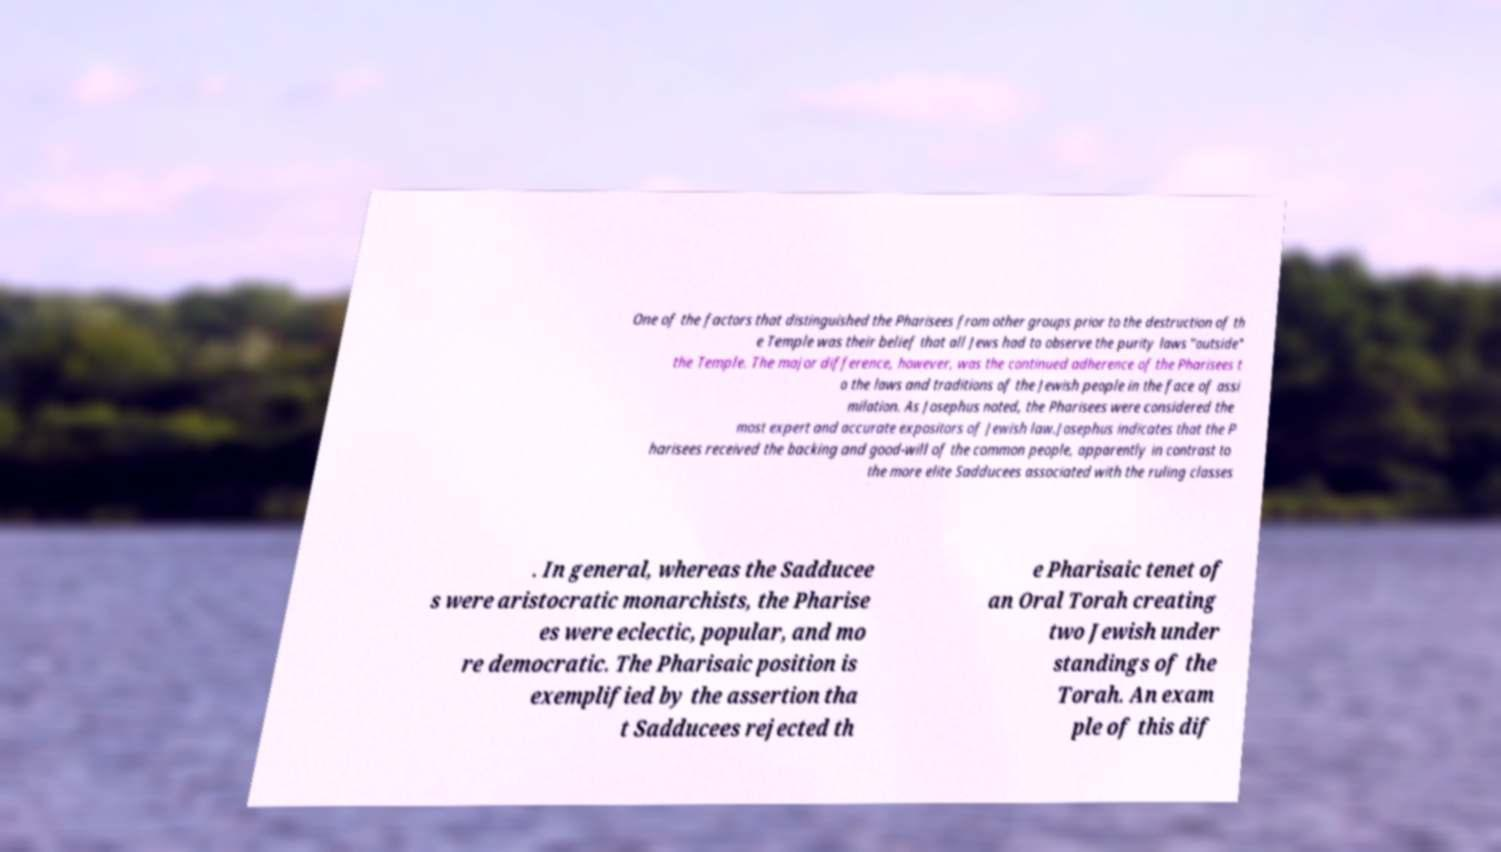I need the written content from this picture converted into text. Can you do that? One of the factors that distinguished the Pharisees from other groups prior to the destruction of th e Temple was their belief that all Jews had to observe the purity laws "outside" the Temple. The major difference, however, was the continued adherence of the Pharisees t o the laws and traditions of the Jewish people in the face of assi milation. As Josephus noted, the Pharisees were considered the most expert and accurate expositors of Jewish law.Josephus indicates that the P harisees received the backing and good-will of the common people, apparently in contrast to the more elite Sadducees associated with the ruling classes . In general, whereas the Sadducee s were aristocratic monarchists, the Pharise es were eclectic, popular, and mo re democratic. The Pharisaic position is exemplified by the assertion tha t Sadducees rejected th e Pharisaic tenet of an Oral Torah creating two Jewish under standings of the Torah. An exam ple of this dif 